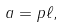<formula> <loc_0><loc_0><loc_500><loc_500>a = p \ell ,</formula> 